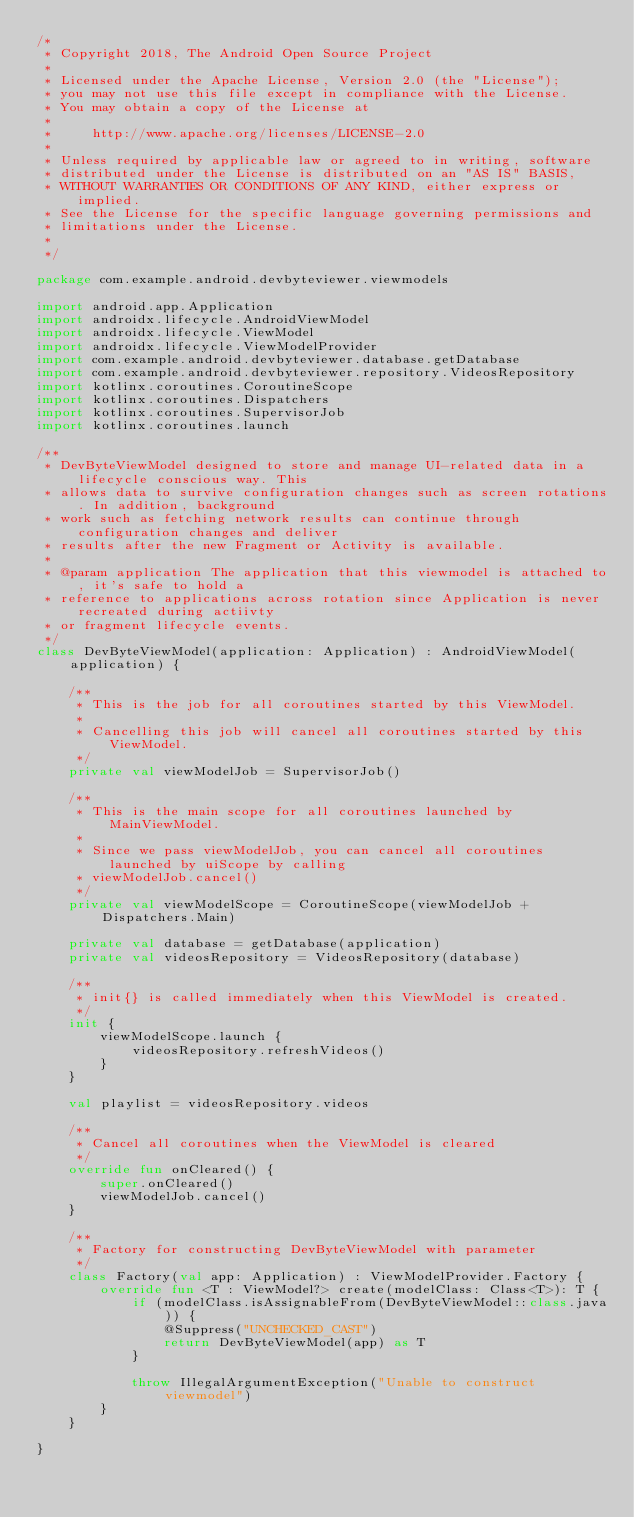<code> <loc_0><loc_0><loc_500><loc_500><_Kotlin_>/*
 * Copyright 2018, The Android Open Source Project
 *
 * Licensed under the Apache License, Version 2.0 (the "License");
 * you may not use this file except in compliance with the License.
 * You may obtain a copy of the License at
 *
 *     http://www.apache.org/licenses/LICENSE-2.0
 *
 * Unless required by applicable law or agreed to in writing, software
 * distributed under the License is distributed on an "AS IS" BASIS,
 * WITHOUT WARRANTIES OR CONDITIONS OF ANY KIND, either express or implied.
 * See the License for the specific language governing permissions and
 * limitations under the License.
 *
 */

package com.example.android.devbyteviewer.viewmodels

import android.app.Application
import androidx.lifecycle.AndroidViewModel
import androidx.lifecycle.ViewModel
import androidx.lifecycle.ViewModelProvider
import com.example.android.devbyteviewer.database.getDatabase
import com.example.android.devbyteviewer.repository.VideosRepository
import kotlinx.coroutines.CoroutineScope
import kotlinx.coroutines.Dispatchers
import kotlinx.coroutines.SupervisorJob
import kotlinx.coroutines.launch

/**
 * DevByteViewModel designed to store and manage UI-related data in a lifecycle conscious way. This
 * allows data to survive configuration changes such as screen rotations. In addition, background
 * work such as fetching network results can continue through configuration changes and deliver
 * results after the new Fragment or Activity is available.
 *
 * @param application The application that this viewmodel is attached to, it's safe to hold a
 * reference to applications across rotation since Application is never recreated during actiivty
 * or fragment lifecycle events.
 */
class DevByteViewModel(application: Application) : AndroidViewModel(application) {

    /**
     * This is the job for all coroutines started by this ViewModel.
     *
     * Cancelling this job will cancel all coroutines started by this ViewModel.
     */
    private val viewModelJob = SupervisorJob()

    /**
     * This is the main scope for all coroutines launched by MainViewModel.
     *
     * Since we pass viewModelJob, you can cancel all coroutines launched by uiScope by calling
     * viewModelJob.cancel()
     */
    private val viewModelScope = CoroutineScope(viewModelJob + Dispatchers.Main)

    private val database = getDatabase(application)
    private val videosRepository = VideosRepository(database)

    /**
     * init{} is called immediately when this ViewModel is created.
     */
    init {
        viewModelScope.launch {
            videosRepository.refreshVideos()
        }
    }

    val playlist = videosRepository.videos

    /**
     * Cancel all coroutines when the ViewModel is cleared
     */
    override fun onCleared() {
        super.onCleared()
        viewModelJob.cancel()
    }

    /**
     * Factory for constructing DevByteViewModel with parameter
     */
    class Factory(val app: Application) : ViewModelProvider.Factory {
        override fun <T : ViewModel?> create(modelClass: Class<T>): T {
            if (modelClass.isAssignableFrom(DevByteViewModel::class.java)) {
                @Suppress("UNCHECKED_CAST")
                return DevByteViewModel(app) as T
            }

            throw IllegalArgumentException("Unable to construct viewmodel")
        }
    }

}
</code> 